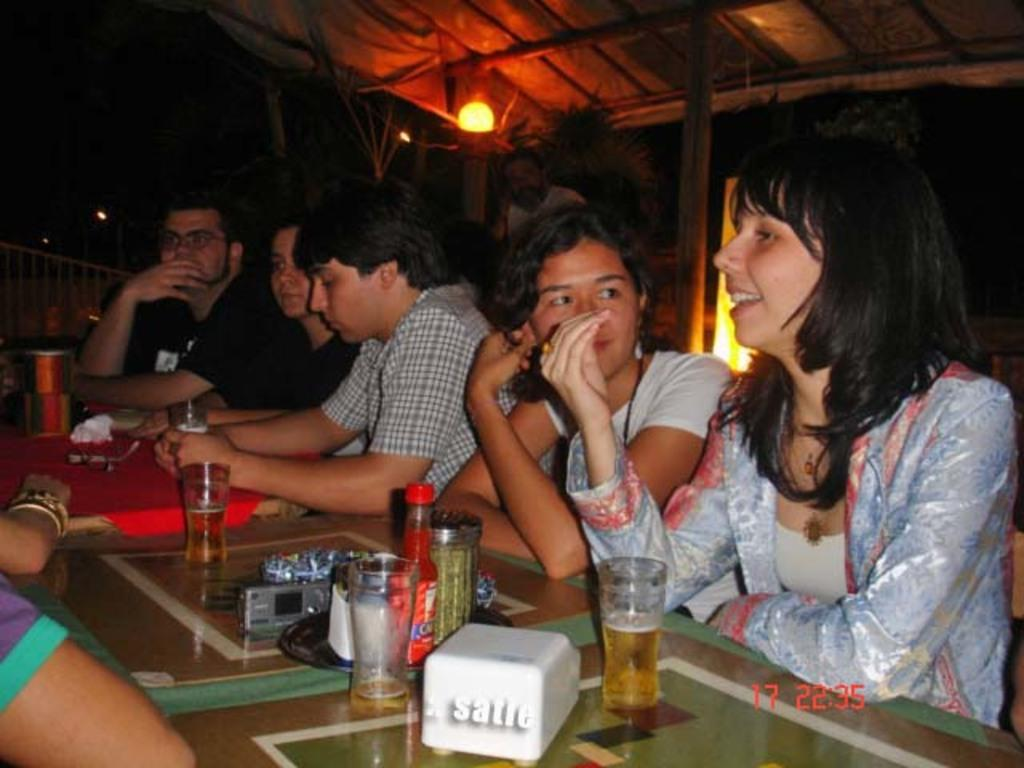How many people are in the image? There are five people in the image, three women and two men. What are the people doing in the image? The people are sitting on chairs. What can be seen on the table in the image? There are glasses, a bottle, and a camera on the table. What is visible in the background of the image? There is a shed and a light in the background. What type of loaf is being used to clean the cobweb in the image? There is no loaf or cobweb present in the image. What is the mindset of the people in the image? The provided facts do not give any information about the mindset or emotions of the people in the image. 